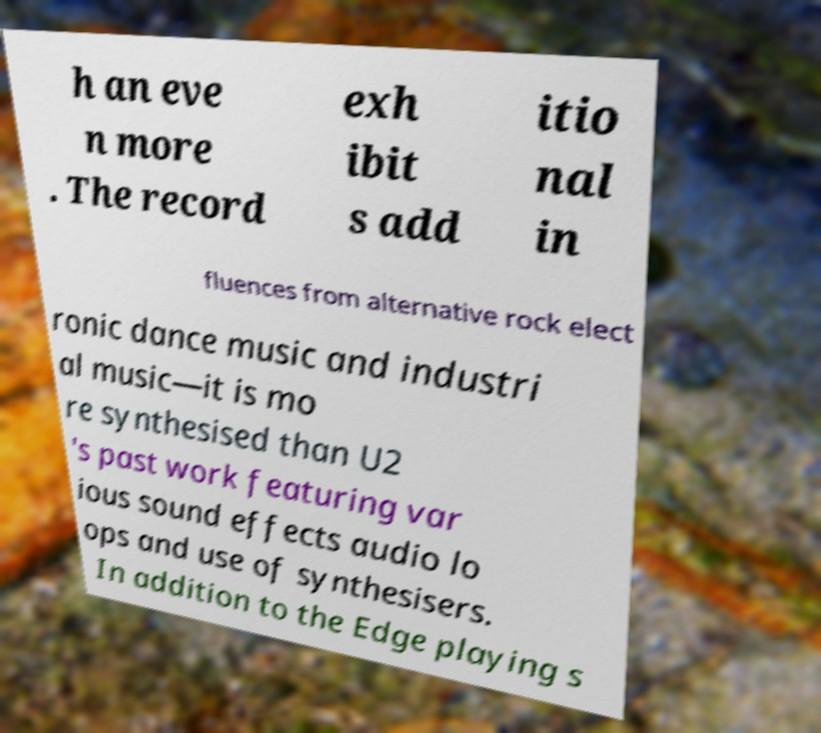Could you assist in decoding the text presented in this image and type it out clearly? h an eve n more . The record exh ibit s add itio nal in fluences from alternative rock elect ronic dance music and industri al music—it is mo re synthesised than U2 's past work featuring var ious sound effects audio lo ops and use of synthesisers. In addition to the Edge playing s 